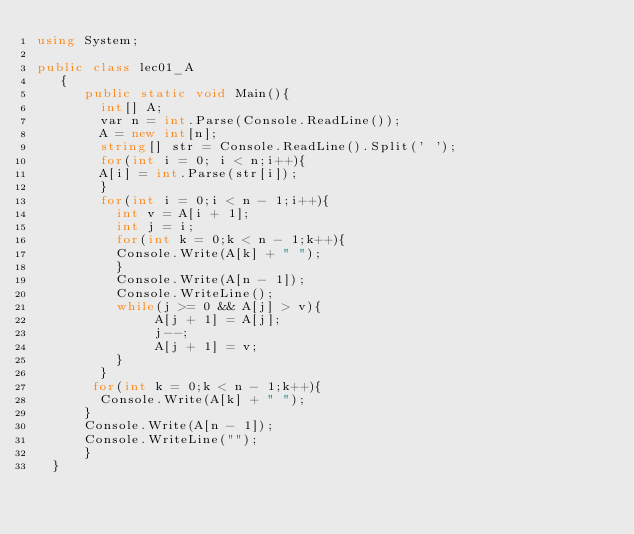Convert code to text. <code><loc_0><loc_0><loc_500><loc_500><_C#_>using System;

public class lec01_A
   {
      public static void Main(){
        int[] A;
        var n = int.Parse(Console.ReadLine());
        A = new int[n];
        string[] str = Console.ReadLine().Split(' ');
        for(int i = 0; i < n;i++){
        A[i] = int.Parse(str[i]);
        }
        for(int i = 0;i < n - 1;i++){
          int v = A[i + 1];
          int j = i;
          for(int k = 0;k < n - 1;k++){
          Console.Write(A[k] + " ");
          }
          Console.Write(A[n - 1]);
          Console.WriteLine();
          while(j >= 0 && A[j] > v){
               A[j + 1] = A[j];
               j--;
               A[j + 1] = v;
          }
        }
       for(int k = 0;k < n - 1;k++){
        Console.Write(A[k] + " ");
      }
      Console.Write(A[n - 1]);
      Console.WriteLine("");
      }
  }
</code> 